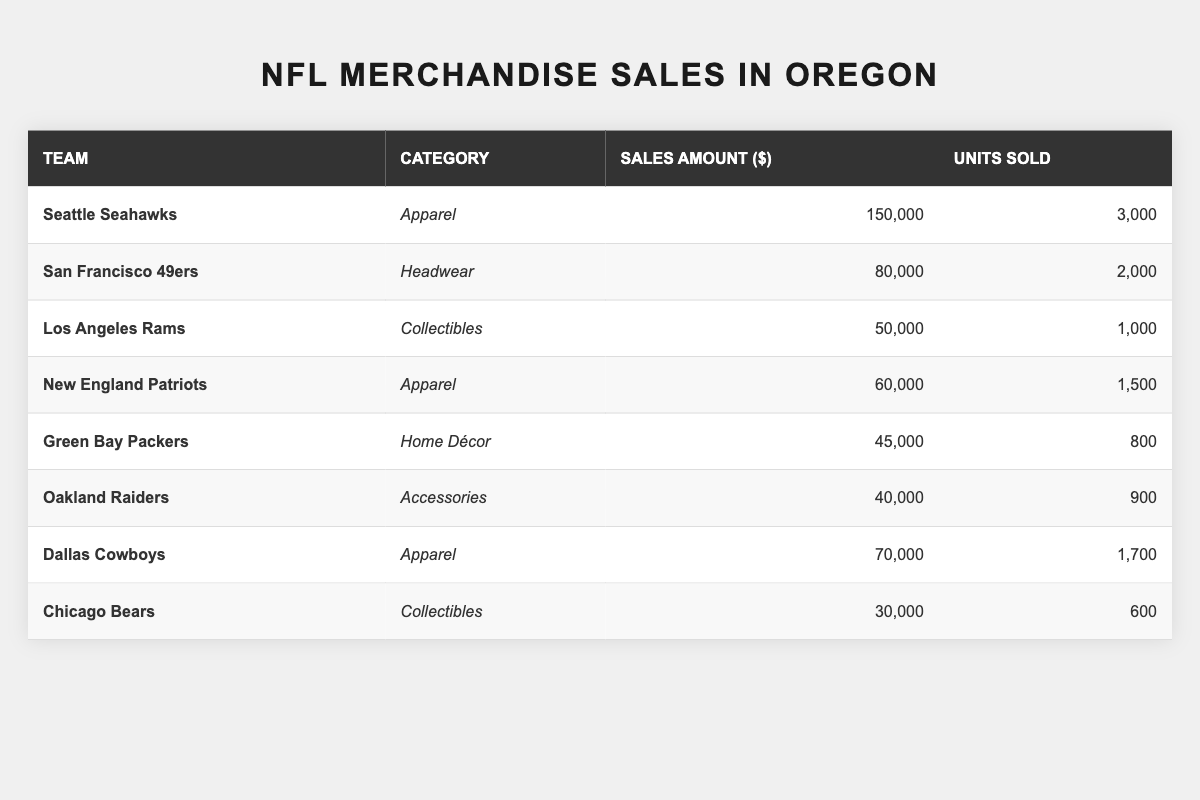What team had the highest sales amount for merchandise in Oregon? From the table, Seattle Seahawks has the highest sales amount at $150,000.
Answer: Seattle Seahawks Which team sold the least number of units? The Chicago Bears sold the least number of units at 600.
Answer: Chicago Bears What was the total sales amount for headwear merchandise? San Francisco 49ers is the only team with headwear, selling $80,000.
Answer: $80,000 Did the Oakland Raiders sell more merchandise than the Green Bay Packers? Oakland Raiders had $40,000 in sales while Green Bay Packers had $45,000. So, no, the Raiders sold less.
Answer: No What is the average sales amount of apparel for the teams listed? The specific apparel sales amounts are $150,000 (Seahawks), $60,000 (Patriots), and $70,000 (Cowboys), totaling $280,000. There are three teams, so the average is $280,000 / 3 = $93,333.33.
Answer: $93,333.33 How many total units were sold for all merchandise categories combined? Adding the units sold: 3000 (Seahawks) + 2000 (49ers) + 1000 (Rams) + 1500 (Patriots) + 800 (Packers) + 900 (Raiders) + 1700 (Cowboys) + 600 (Bears) equals 10,500.
Answer: 10,500 Which category of merchandise generated the most revenue? The highest sales amount is from Apparel, totaling $150,000 (Seahawks) + $60,000 (Patriots) + $70,000 (Cowboys) = $280,000.
Answer: Apparel What percentage of total sales came from the Seattle Seahawks? The total sales amount is $150,000 + $80,000 + $50,000 + $60,000 + $45,000 + $40,000 + $70,000 + $30,000 = $525,000. Seattle's sales are $150,000, so the percentage is ($150,000 / $525,000) * 100 ≈ 28.57%.
Answer: 28.57% Which team had more sales amount, the Los Angeles Rams or the New England Patriots? The Rams had $50,000 while the Patriots had $60,000. Thus, the Patriots had more sales.
Answer: New England Patriots If the Green Bay Packers’ sales increased by 10%, what would be their new sales amount? The current sales amount is $45,000. A 10% increase is $45,000 * 0.10 = $4,500. Adding this gives $45,000 + $4,500 = $49,500.
Answer: $49,500 